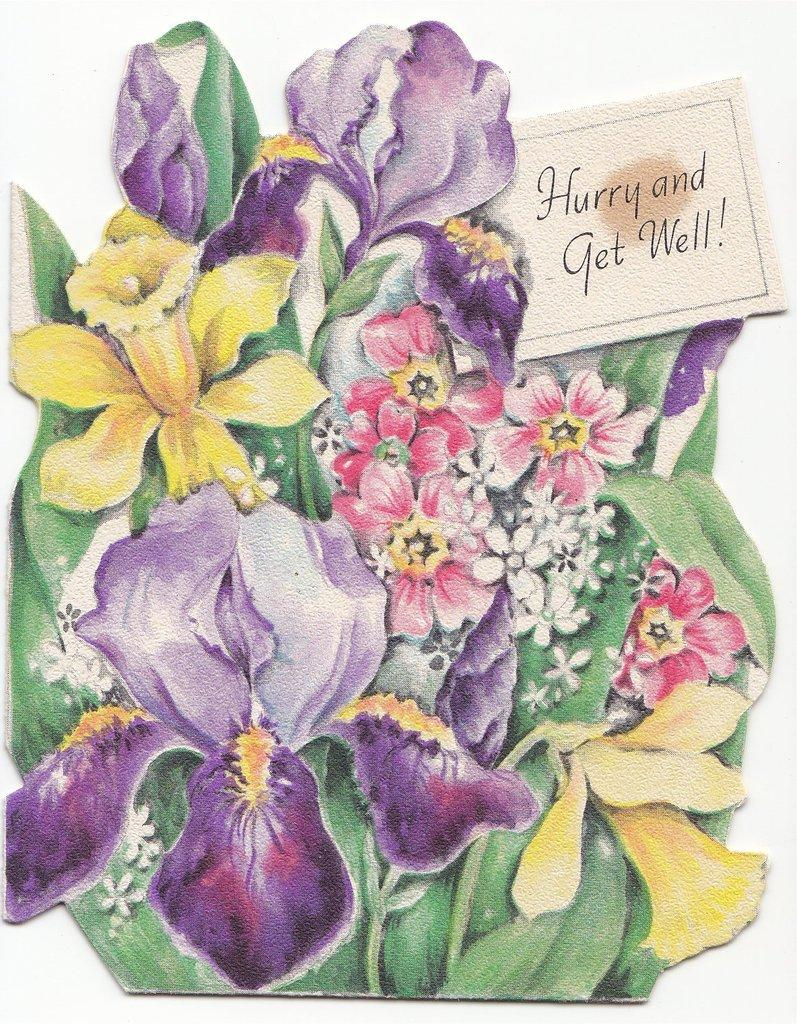What is the main subject of the image? The main subject of the image is a picture of a bouquet. What else can be seen in the image besides the bouquet? There is a card in the image. Can you describe the card in the image? Yes, there is text on the card in the image. What type of jewel can be seen on the crow in the image? There is no crow or jewel present in the image. 